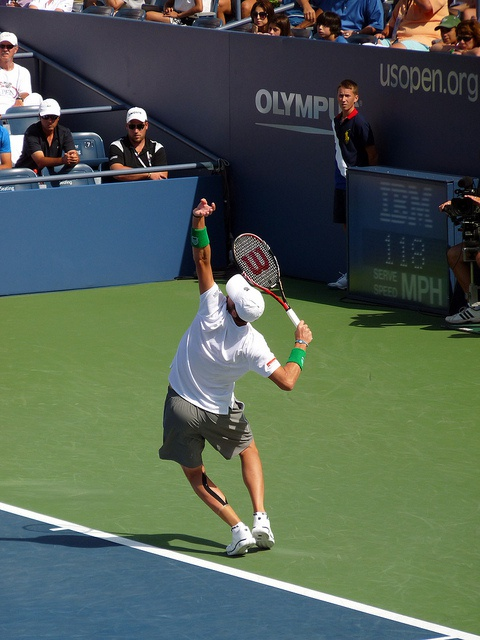Describe the objects in this image and their specific colors. I can see people in black, olive, white, and gray tones, people in black, maroon, and gray tones, people in black, white, maroon, and darkgray tones, people in black, maroon, white, and brown tones, and tennis racket in black, gray, darkgray, and maroon tones in this image. 